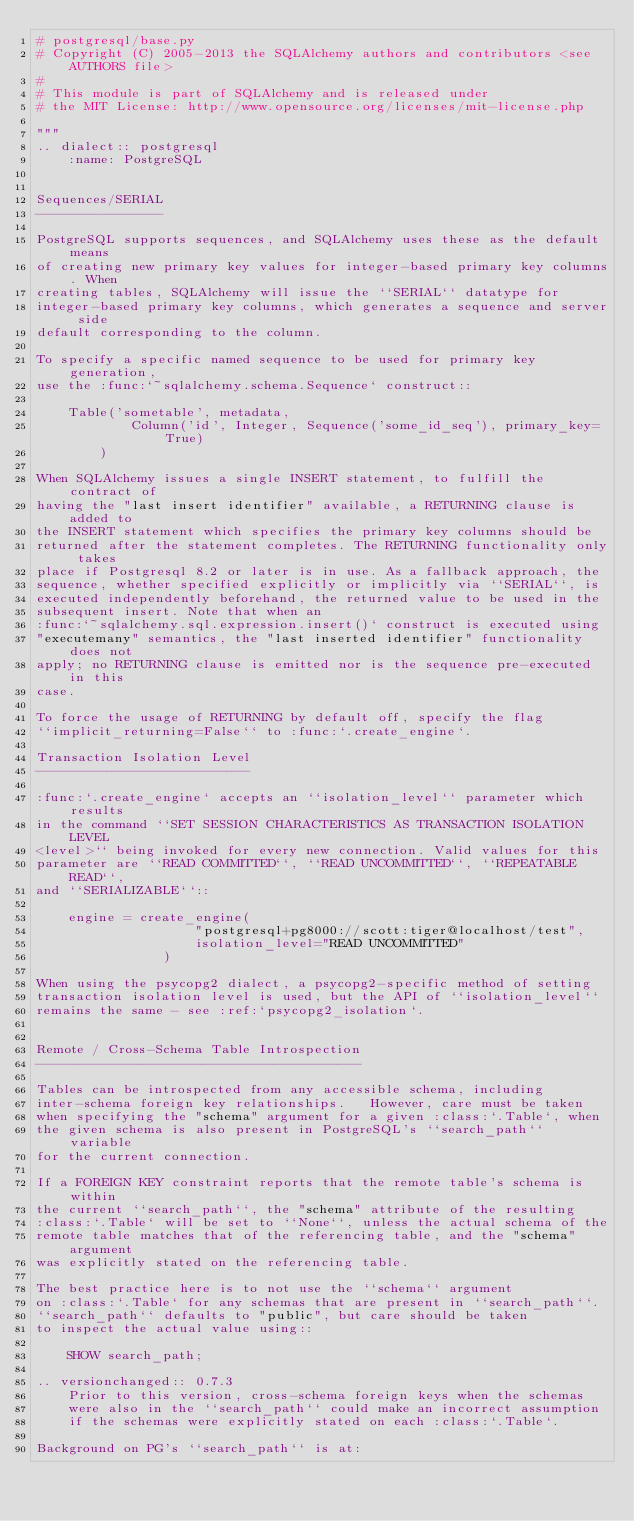<code> <loc_0><loc_0><loc_500><loc_500><_Python_># postgresql/base.py
# Copyright (C) 2005-2013 the SQLAlchemy authors and contributors <see AUTHORS file>
#
# This module is part of SQLAlchemy and is released under
# the MIT License: http://www.opensource.org/licenses/mit-license.php

"""
.. dialect:: postgresql
    :name: PostgreSQL


Sequences/SERIAL
----------------

PostgreSQL supports sequences, and SQLAlchemy uses these as the default means
of creating new primary key values for integer-based primary key columns. When
creating tables, SQLAlchemy will issue the ``SERIAL`` datatype for
integer-based primary key columns, which generates a sequence and server side
default corresponding to the column.

To specify a specific named sequence to be used for primary key generation,
use the :func:`~sqlalchemy.schema.Sequence` construct::

    Table('sometable', metadata,
            Column('id', Integer, Sequence('some_id_seq'), primary_key=True)
        )

When SQLAlchemy issues a single INSERT statement, to fulfill the contract of
having the "last insert identifier" available, a RETURNING clause is added to
the INSERT statement which specifies the primary key columns should be
returned after the statement completes. The RETURNING functionality only takes
place if Postgresql 8.2 or later is in use. As a fallback approach, the
sequence, whether specified explicitly or implicitly via ``SERIAL``, is
executed independently beforehand, the returned value to be used in the
subsequent insert. Note that when an
:func:`~sqlalchemy.sql.expression.insert()` construct is executed using
"executemany" semantics, the "last inserted identifier" functionality does not
apply; no RETURNING clause is emitted nor is the sequence pre-executed in this
case.

To force the usage of RETURNING by default off, specify the flag
``implicit_returning=False`` to :func:`.create_engine`.

Transaction Isolation Level
---------------------------

:func:`.create_engine` accepts an ``isolation_level`` parameter which results
in the command ``SET SESSION CHARACTERISTICS AS TRANSACTION ISOLATION LEVEL
<level>`` being invoked for every new connection. Valid values for this
parameter are ``READ COMMITTED``, ``READ UNCOMMITTED``, ``REPEATABLE READ``,
and ``SERIALIZABLE``::

    engine = create_engine(
                    "postgresql+pg8000://scott:tiger@localhost/test",
                    isolation_level="READ UNCOMMITTED"
                )

When using the psycopg2 dialect, a psycopg2-specific method of setting
transaction isolation level is used, but the API of ``isolation_level``
remains the same - see :ref:`psycopg2_isolation`.


Remote / Cross-Schema Table Introspection
-----------------------------------------

Tables can be introspected from any accessible schema, including
inter-schema foreign key relationships.   However, care must be taken
when specifying the "schema" argument for a given :class:`.Table`, when
the given schema is also present in PostgreSQL's ``search_path`` variable
for the current connection.

If a FOREIGN KEY constraint reports that the remote table's schema is within
the current ``search_path``, the "schema" attribute of the resulting
:class:`.Table` will be set to ``None``, unless the actual schema of the
remote table matches that of the referencing table, and the "schema" argument
was explicitly stated on the referencing table.

The best practice here is to not use the ``schema`` argument
on :class:`.Table` for any schemas that are present in ``search_path``.
``search_path`` defaults to "public", but care should be taken
to inspect the actual value using::

    SHOW search_path;

.. versionchanged:: 0.7.3
    Prior to this version, cross-schema foreign keys when the schemas
    were also in the ``search_path`` could make an incorrect assumption
    if the schemas were explicitly stated on each :class:`.Table`.

Background on PG's ``search_path`` is at:</code> 